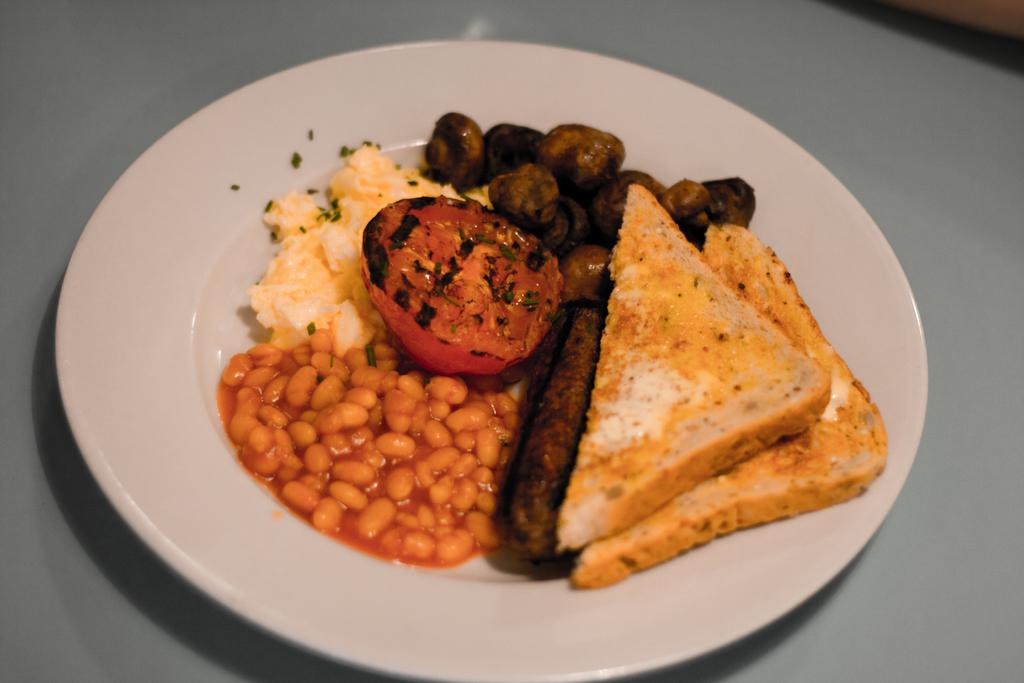What is located in the center of the image? There is a table in the center of the image. What is placed on the table? There is a plate on the table. What can be found on the plate? There are food items in the plate. What type of cherry is used as a garnish on the food items in the image? There is no cherry present in the image, as the provided facts only mention food items on the plate. 